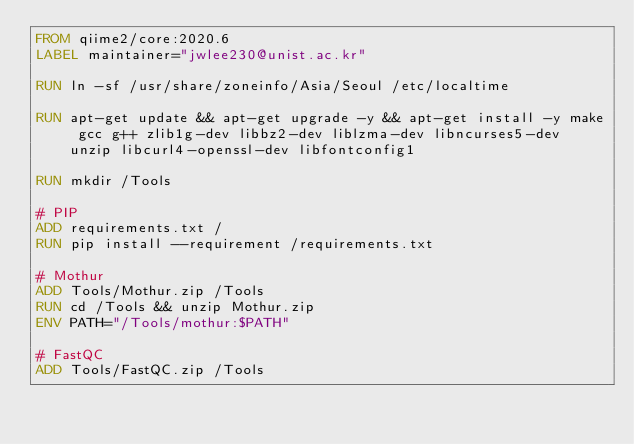Convert code to text. <code><loc_0><loc_0><loc_500><loc_500><_Dockerfile_>FROM qiime2/core:2020.6
LABEL maintainer="jwlee230@unist.ac.kr"

RUN ln -sf /usr/share/zoneinfo/Asia/Seoul /etc/localtime

RUN apt-get update && apt-get upgrade -y && apt-get install -y make gcc g++ zlib1g-dev libbz2-dev liblzma-dev libncurses5-dev unzip libcurl4-openssl-dev libfontconfig1

RUN mkdir /Tools

# PIP
ADD requirements.txt /
RUN pip install --requirement /requirements.txt

# Mothur
ADD Tools/Mothur.zip /Tools
RUN cd /Tools && unzip Mothur.zip
ENV PATH="/Tools/mothur:$PATH"

# FastQC
ADD Tools/FastQC.zip /Tools</code> 